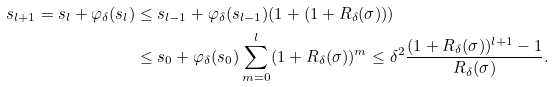<formula> <loc_0><loc_0><loc_500><loc_500>s _ { l + 1 } = s _ { l } + \varphi _ { \delta } ( s _ { l } ) & \leq s _ { l - 1 } + \varphi _ { \delta } ( s _ { l - 1 } ) ( 1 + ( 1 + R _ { \delta } ( \sigma ) ) ) \\ & \leq s _ { 0 } + \varphi _ { \delta } ( s _ { 0 } ) \sum _ { m = 0 } ^ { l } ( 1 + R _ { \delta } ( \sigma ) ) ^ { m } \leq \delta ^ { 2 } \frac { ( 1 + R _ { \delta } ( \sigma ) ) ^ { l + 1 } - 1 } { R _ { \delta } ( \sigma ) } .</formula> 